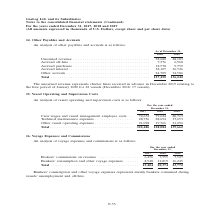According to Gaslog's financial document, What is being analyzed as shown in the table? Vessel operating and supervision costs. The document states: "15. Vessel Operating and Supervision Costs..." Also, What are the components of vessel operating and supervision costs? The document contains multiple relevant values: Crew wages and vessel management employee costs, Technical maintenance expenses, Other vessel operating expenses. From the document: "Crew wages and vessel management employee costs . 72,652 79,624 80,713 Technical maintenance expenses . 28,736 28,694 37,653 Other vessel operating ni..." Also, What is the total amount in 2017? According to the financial document, 122,486 (in thousands). The relevant text states: "Total . 122,486 128,084 139,662..." Additionally, In which year was the crew wages and vessel management employee costs the lowest? According to the financial document, 2017. The relevant text states: "For the year ended December 31, 2017 2018 2019..." Also, can you calculate: What was the change in technical maintenance expenses from 2017 to 2018? Based on the calculation: 28,694 - 28,736 , the result is -42 (in thousands). This is based on the information: "24 80,713 Technical maintenance expenses . 28,736 28,694 37,653 Other vessel operating expenses . 21,098 19,766 21,296 52 79,624 80,713 Technical maintenance expenses . 28,736 28,694 37,653 Other vess..." The key data points involved are: 28,694, 28,736. Also, can you calculate: What was the percentage change in total vessel operating and supervision costs from 2018 to 2019? To answer this question, I need to perform calculations using the financial data. The calculation is: (139,662 - 128,084)/128,084 , which equals 9.04 (percentage). This is based on the information: "Total . 122,486 128,084 139,662 Total . 122,486 128,084 139,662..." The key data points involved are: 128,084, 139,662. 